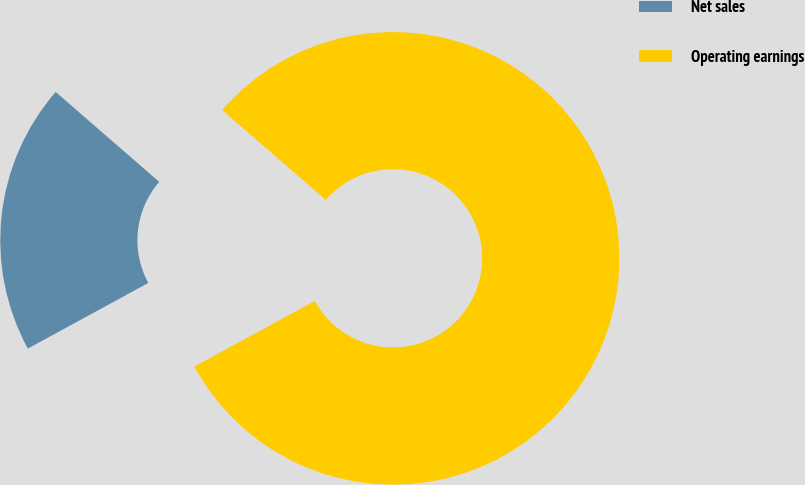Convert chart. <chart><loc_0><loc_0><loc_500><loc_500><pie_chart><fcel>Net sales<fcel>Operating earnings<nl><fcel>19.32%<fcel>80.68%<nl></chart> 